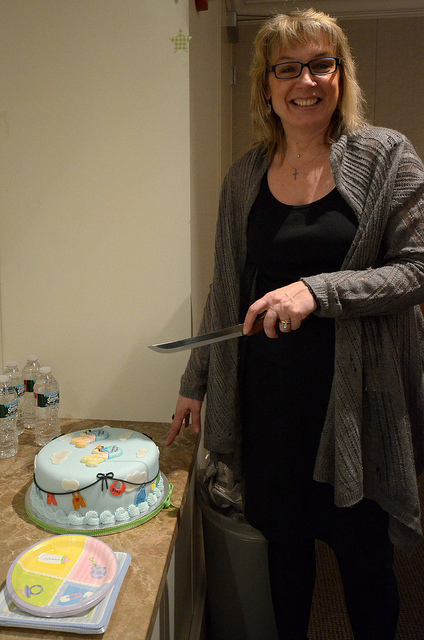<image>What color hair does the woman in the red shirt have? There is no woman in a red shirt in the image. However, if there is one, her hair might be blonde. What color hair does the woman in the red shirt have? I am not sure what color hair the woman in the red shirt has. 